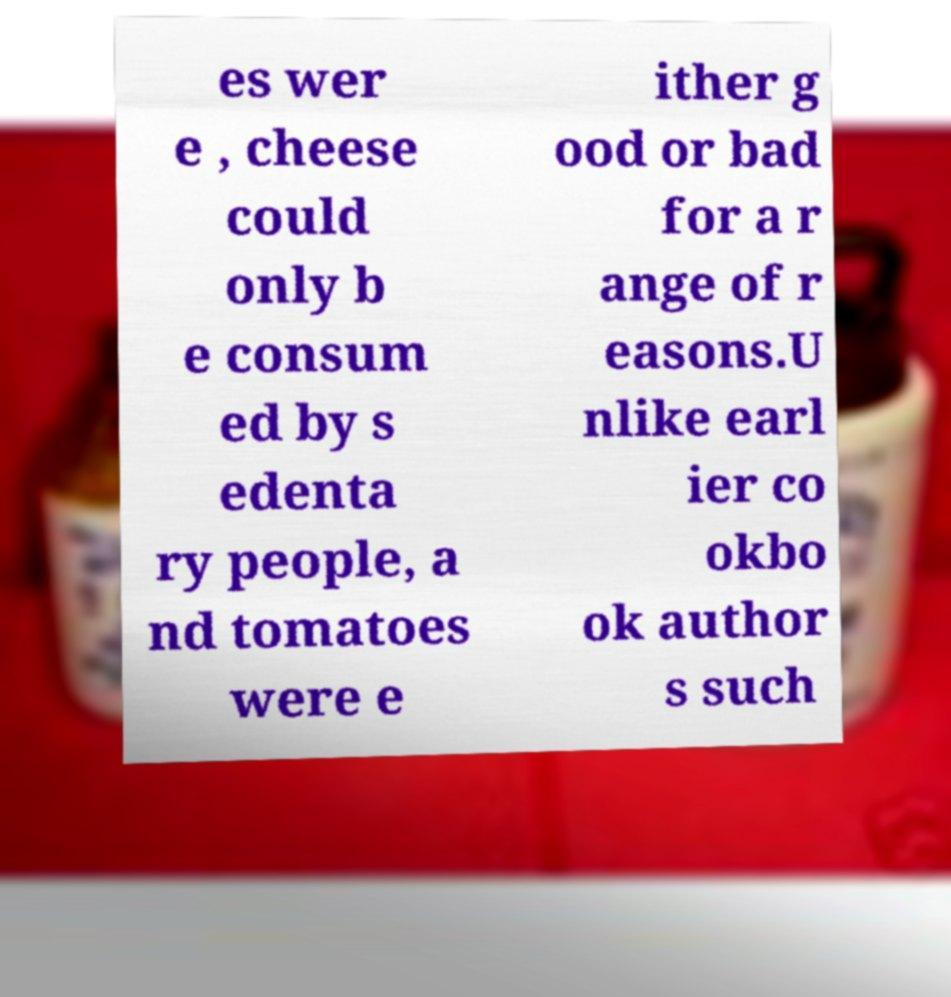I need the written content from this picture converted into text. Can you do that? es wer e , cheese could only b e consum ed by s edenta ry people, a nd tomatoes were e ither g ood or bad for a r ange of r easons.U nlike earl ier co okbo ok author s such 